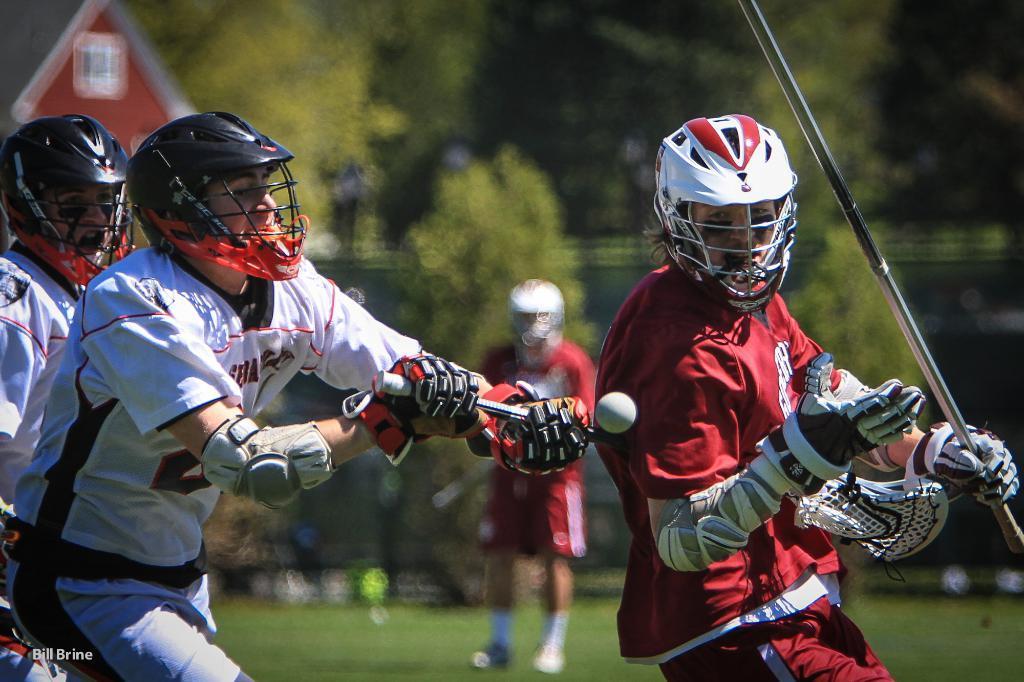Describe this image in one or two sentences. In this image, we can see people wearing helmets and holding sticks in their hands and there is a ball. In the background, we can see a board and trees and there is a person standing. At the bottom, there is ground and we can see some text. 